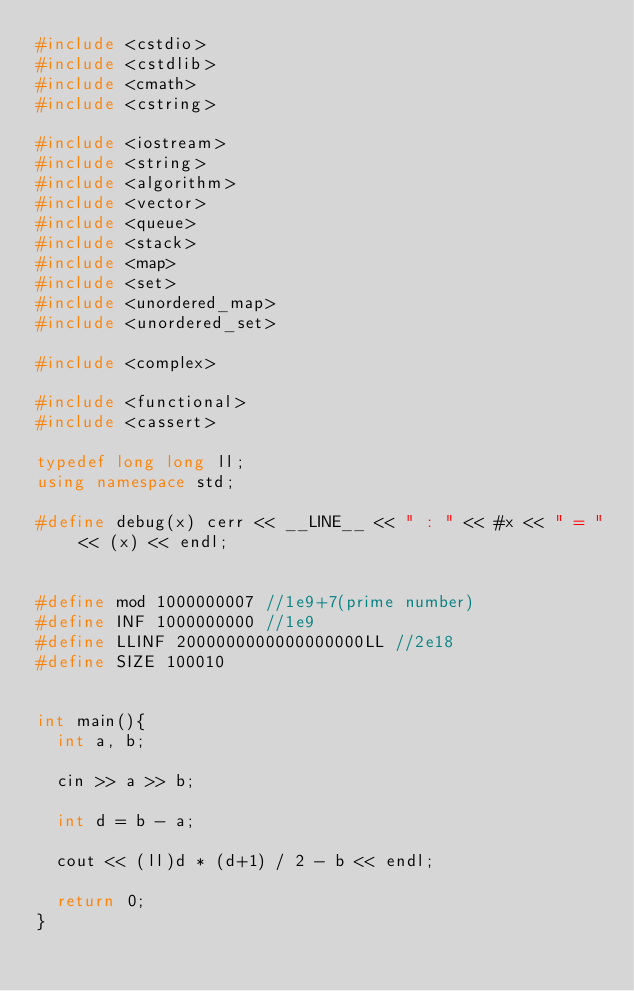Convert code to text. <code><loc_0><loc_0><loc_500><loc_500><_C++_>#include <cstdio>
#include <cstdlib>
#include <cmath>
#include <cstring>

#include <iostream>
#include <string>
#include <algorithm>
#include <vector>
#include <queue>
#include <stack>
#include <map>
#include <set>
#include <unordered_map>
#include <unordered_set>

#include <complex>

#include <functional>
#include <cassert>

typedef long long ll;
using namespace std;

#define debug(x) cerr << __LINE__ << " : " << #x << " = " << (x) << endl;


#define mod 1000000007 //1e9+7(prime number)
#define INF 1000000000 //1e9
#define LLINF 2000000000000000000LL //2e18
#define SIZE 100010


int main(){
  int a, b;

  cin >> a >> b;

  int d = b - a;

  cout << (ll)d * (d+1) / 2 - b << endl;
  
  return 0;
}
</code> 